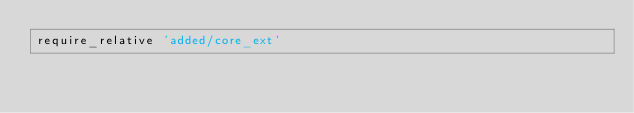<code> <loc_0><loc_0><loc_500><loc_500><_Ruby_>require_relative 'added/core_ext'
</code> 